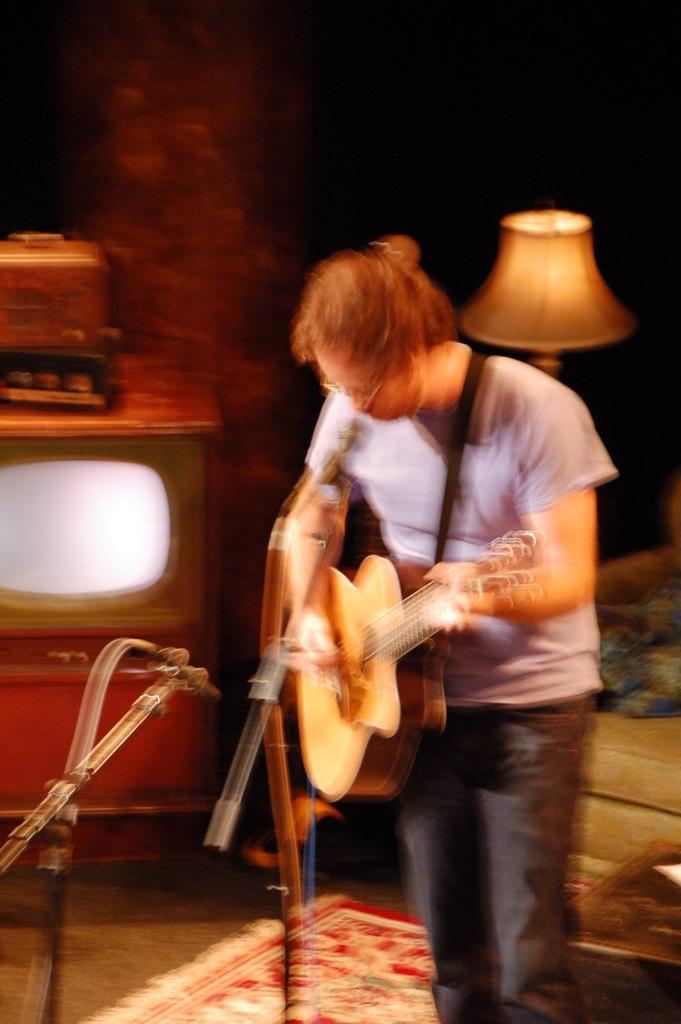Could you give a brief overview of what you see in this image? This image is clicked in a musical concert where a man is standing and he is some, singing something ,a mic is in front of him. He is playing a guitar, he wore white shirt and black pant. there is television on the left side and there is a lamp on the right side, there is a table in the right side bottom corner. There is also a carpet in the bottom. 